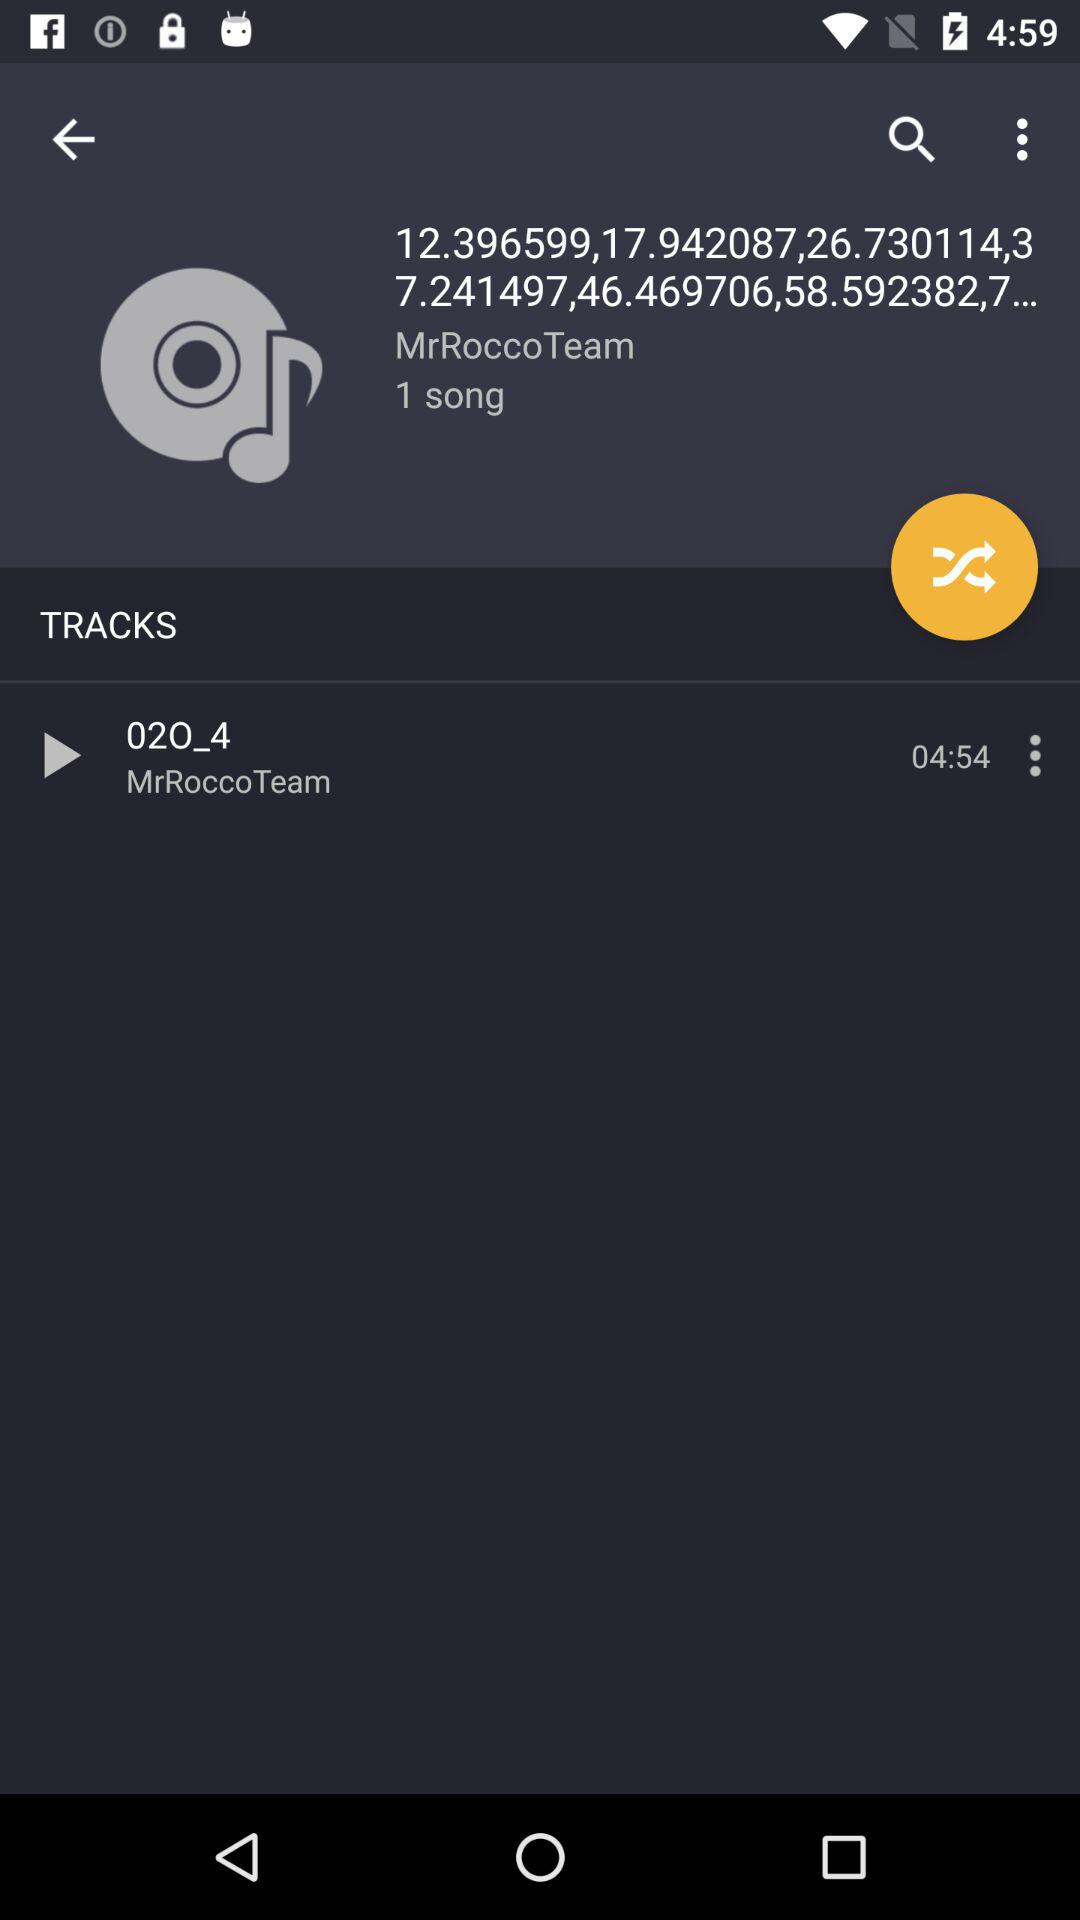What is the number of songs? There is only one song. 